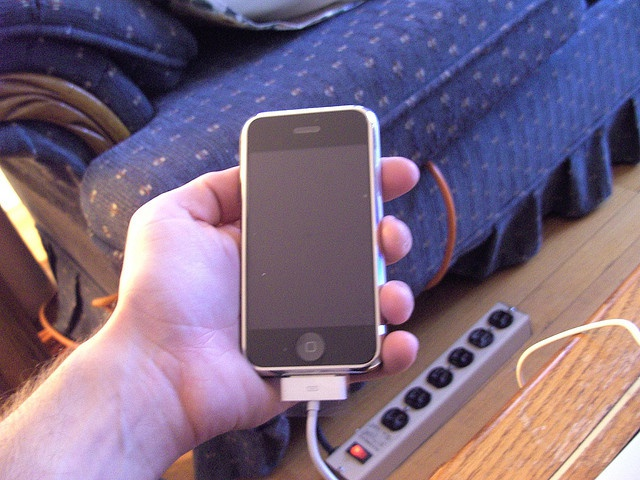Describe the objects in this image and their specific colors. I can see couch in blue, navy, black, and purple tones, people in blue, violet, lavender, and lightpink tones, and cell phone in blue, gray, black, and lightgray tones in this image. 